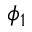Convert formula to latex. <formula><loc_0><loc_0><loc_500><loc_500>\phi _ { 1 }</formula> 